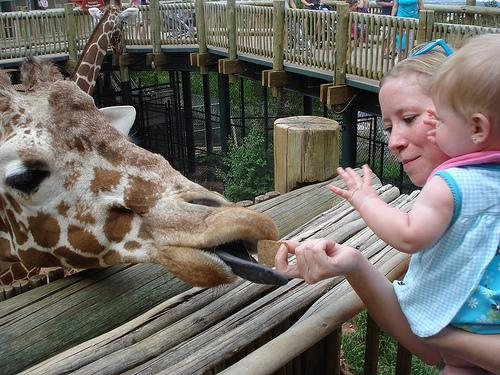Question: what is the mother giving the giraffe?
Choices:
A. Hay.
B. Food.
C. Love.
D. Milk.
Answer with the letter. Answer: B Question: where was this taken?
Choices:
A. An observatory.
B. A zoo.
C. A museum.
D. A botanical garden.
Answer with the letter. Answer: B Question: what is the fence made of?
Choices:
A. Wood.
B. Steel.
C. Barbed wire.
D. Composite materials.
Answer with the letter. Answer: A Question: how many giraffes are there?
Choices:
A. Two.
B. One.
C. Three.
D. Four.
Answer with the letter. Answer: A Question: what animal is sticking out its tongue?
Choices:
A. Monkey.
B. Horse.
C. Giraffe.
D. Sheep.
Answer with the letter. Answer: C 